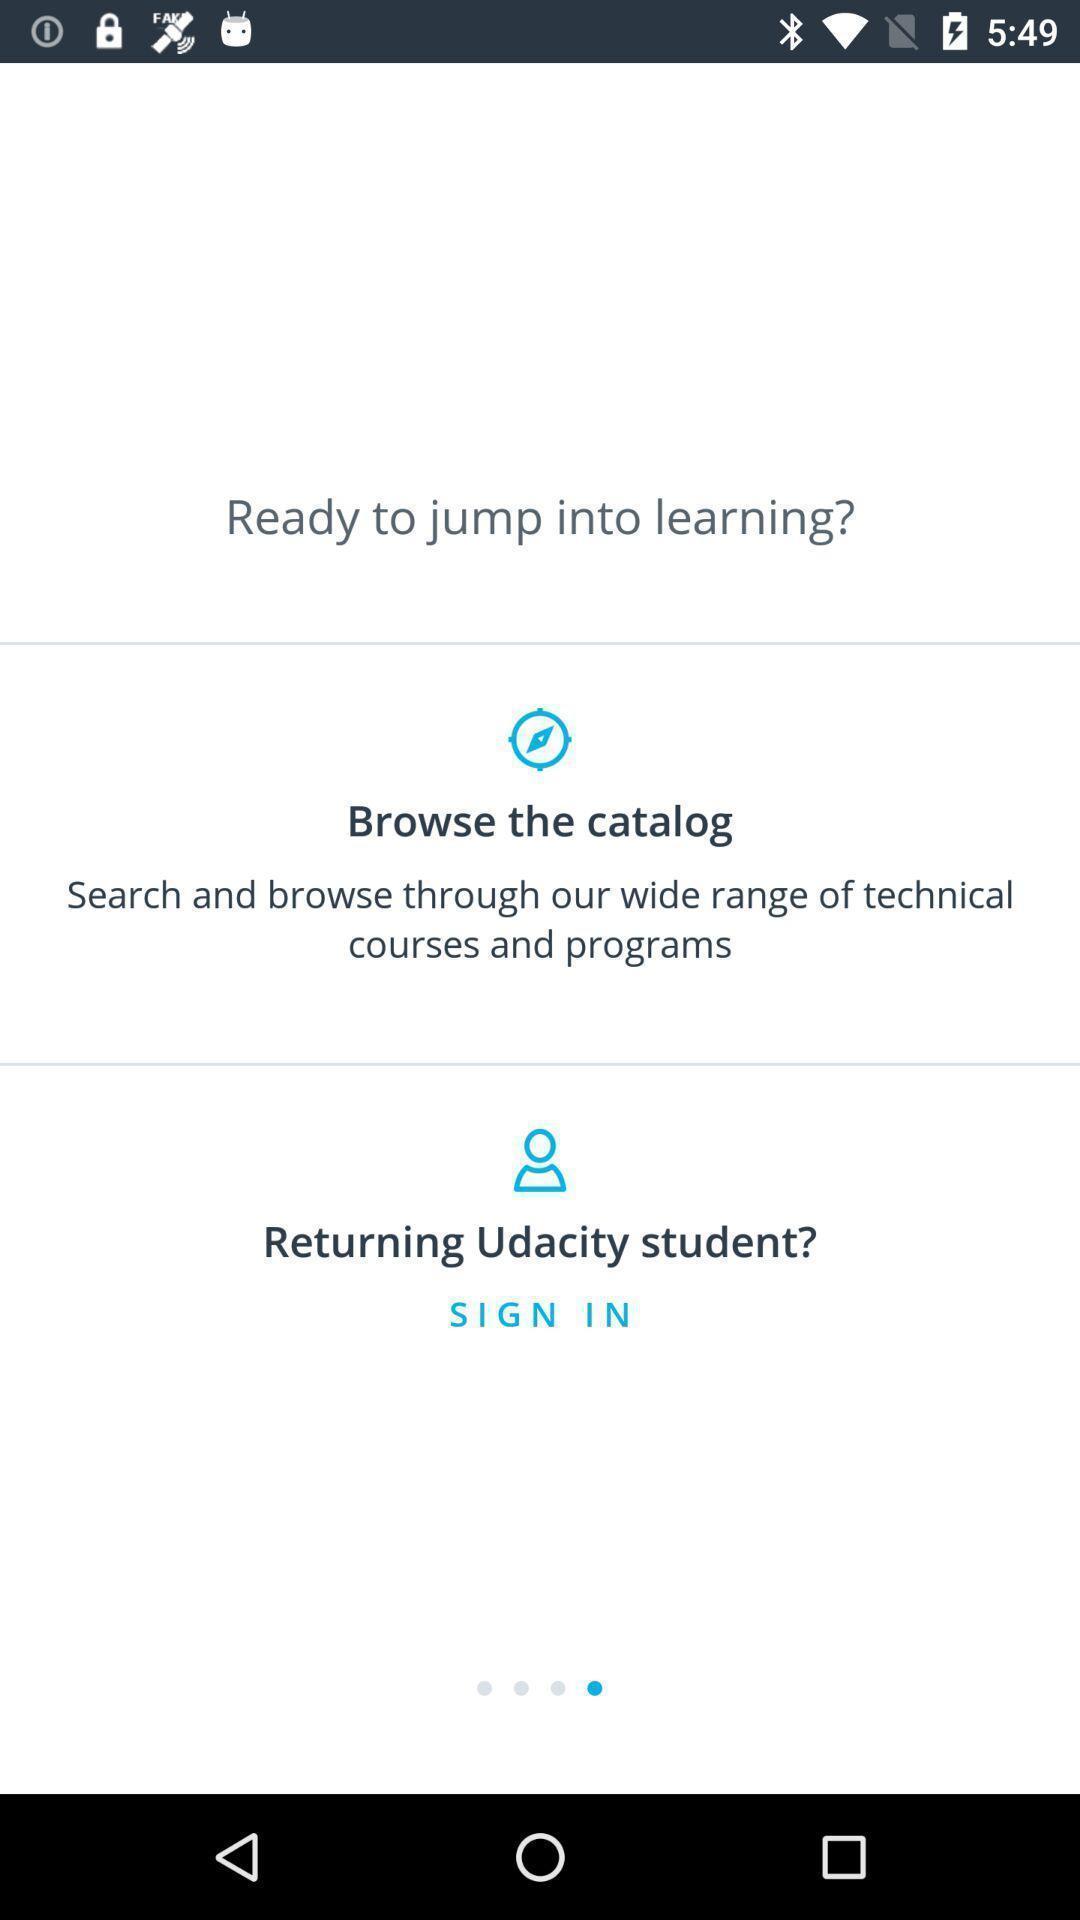Give me a summary of this screen capture. Welcome page with sign in options for a learning app. 